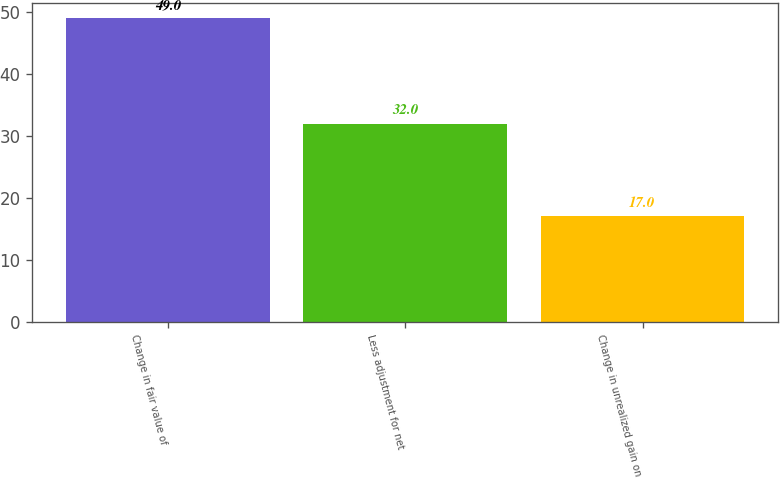Convert chart. <chart><loc_0><loc_0><loc_500><loc_500><bar_chart><fcel>Change in fair value of<fcel>Less adjustment for net<fcel>Change in unrealized gain on<nl><fcel>49<fcel>32<fcel>17<nl></chart> 